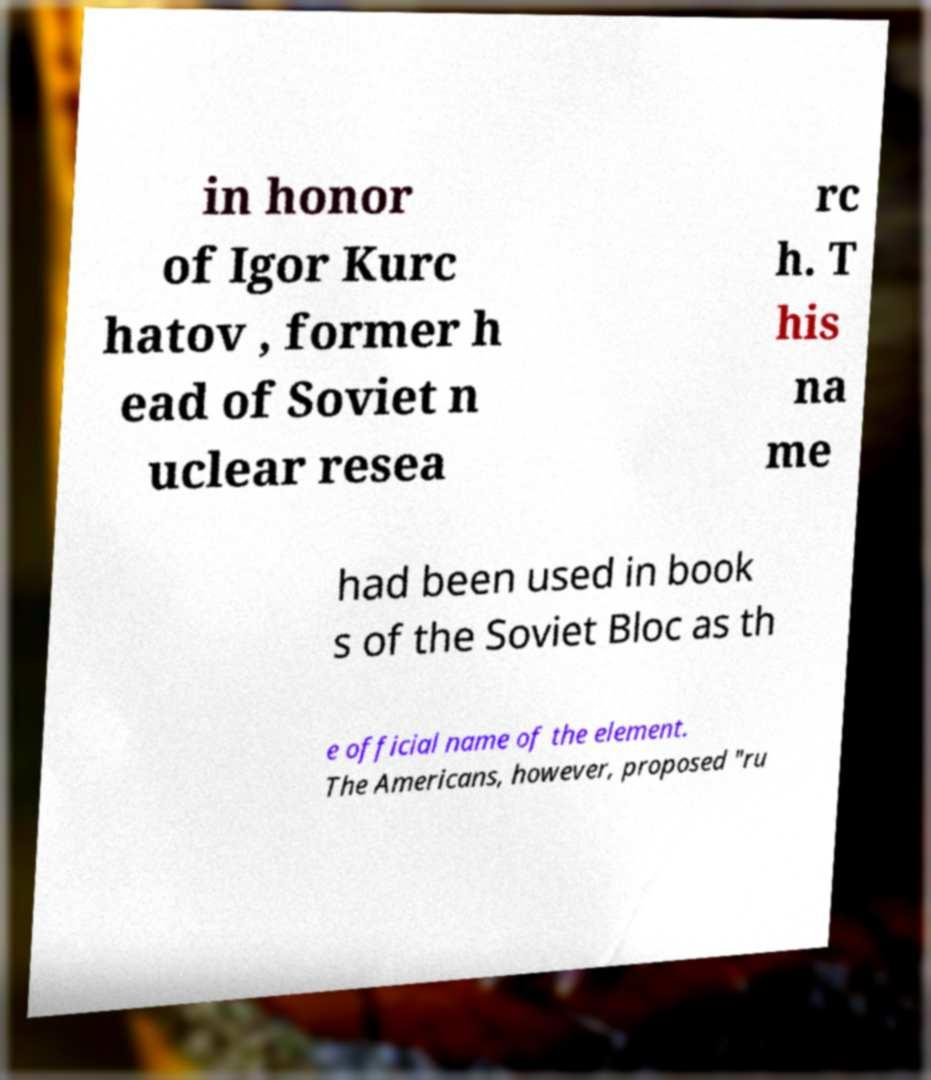Could you extract and type out the text from this image? in honor of Igor Kurc hatov , former h ead of Soviet n uclear resea rc h. T his na me had been used in book s of the Soviet Bloc as th e official name of the element. The Americans, however, proposed "ru 